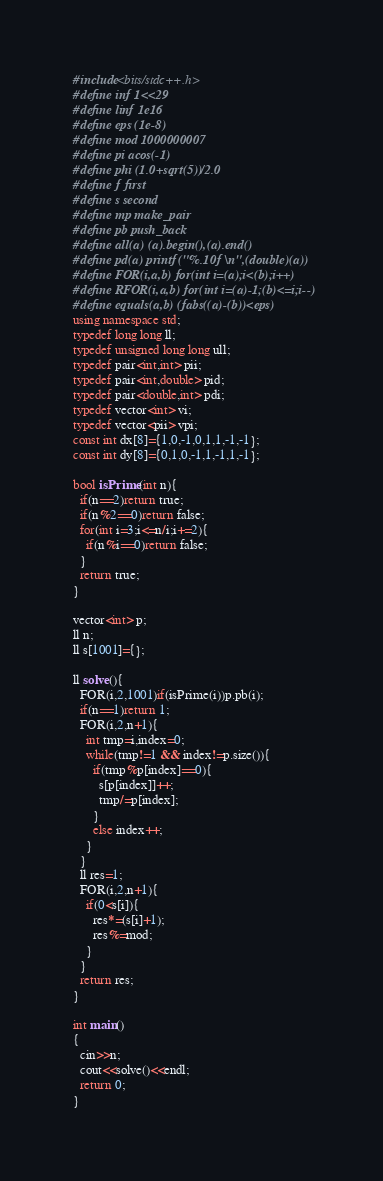Convert code to text. <code><loc_0><loc_0><loc_500><loc_500><_C++_>#include<bits/stdc++.h>
#define inf 1<<29
#define linf 1e16
#define eps (1e-8)
#define mod 1000000007
#define pi acos(-1)
#define phi (1.0+sqrt(5))/2.0
#define f first
#define s second
#define mp make_pair
#define pb push_back
#define all(a) (a).begin(),(a).end()
#define pd(a) printf("%.10f\n",(double)(a))
#define FOR(i,a,b) for(int i=(a);i<(b);i++)
#define RFOR(i,a,b) for(int i=(a)-1;(b)<=i;i--)
#define equals(a,b) (fabs((a)-(b))<eps)
using namespace std;
typedef long long ll;
typedef unsigned long long ull;
typedef pair<int,int> pii;
typedef pair<int,double> pid;
typedef pair<double,int> pdi;
typedef vector<int> vi;
typedef vector<pii> vpi;
const int dx[8]={1,0,-1,0,1,1,-1,-1};
const int dy[8]={0,1,0,-1,1,-1,1,-1};

bool isPrime(int n){
  if(n==2)return true;
  if(n%2==0)return false;
  for(int i=3;i<=n/i;i+=2){
    if(n%i==0)return false;
  }
  return true;
}

vector<int> p;
ll n;
ll s[1001]={};

ll solve(){
  FOR(i,2,1001)if(isPrime(i))p.pb(i);
  if(n==1)return 1;
  FOR(i,2,n+1){
    int tmp=i,index=0;
    while(tmp!=1 && index!=p.size()){
      if(tmp%p[index]==0){
        s[p[index]]++;
        tmp/=p[index];
      }
      else index++;
    }
  }
  ll res=1;
  FOR(i,2,n+1){
    if(0<s[i]){
      res*=(s[i]+1);
      res%=mod;
    }
  }
  return res;
}

int main()
{
  cin>>n;
  cout<<solve()<<endl;
  return 0;
}

</code> 